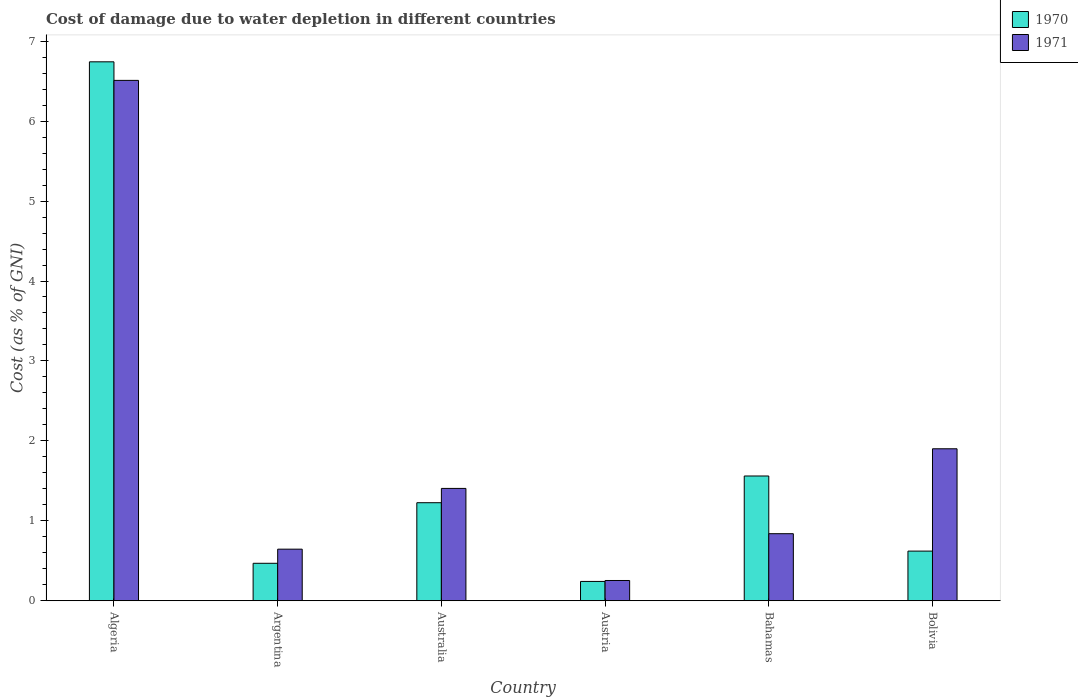How many different coloured bars are there?
Your answer should be compact. 2. How many groups of bars are there?
Make the answer very short. 6. Are the number of bars on each tick of the X-axis equal?
Offer a very short reply. Yes. How many bars are there on the 1st tick from the left?
Provide a short and direct response. 2. What is the label of the 3rd group of bars from the left?
Provide a short and direct response. Australia. In how many cases, is the number of bars for a given country not equal to the number of legend labels?
Your answer should be very brief. 0. What is the cost of damage caused due to water depletion in 1971 in Australia?
Provide a succinct answer. 1.41. Across all countries, what is the maximum cost of damage caused due to water depletion in 1970?
Offer a very short reply. 6.74. Across all countries, what is the minimum cost of damage caused due to water depletion in 1970?
Provide a succinct answer. 0.24. In which country was the cost of damage caused due to water depletion in 1971 maximum?
Offer a terse response. Algeria. In which country was the cost of damage caused due to water depletion in 1971 minimum?
Give a very brief answer. Austria. What is the total cost of damage caused due to water depletion in 1970 in the graph?
Keep it short and to the point. 10.86. What is the difference between the cost of damage caused due to water depletion in 1970 in Argentina and that in Bahamas?
Provide a succinct answer. -1.09. What is the difference between the cost of damage caused due to water depletion in 1971 in Australia and the cost of damage caused due to water depletion in 1970 in Algeria?
Your answer should be very brief. -5.34. What is the average cost of damage caused due to water depletion in 1971 per country?
Your answer should be compact. 1.93. What is the difference between the cost of damage caused due to water depletion of/in 1971 and cost of damage caused due to water depletion of/in 1970 in Australia?
Provide a succinct answer. 0.18. In how many countries, is the cost of damage caused due to water depletion in 1971 greater than 4.6 %?
Your answer should be very brief. 1. What is the ratio of the cost of damage caused due to water depletion in 1971 in Algeria to that in Australia?
Ensure brevity in your answer.  4.63. Is the difference between the cost of damage caused due to water depletion in 1971 in Algeria and Argentina greater than the difference between the cost of damage caused due to water depletion in 1970 in Algeria and Argentina?
Provide a short and direct response. No. What is the difference between the highest and the second highest cost of damage caused due to water depletion in 1971?
Your response must be concise. -4.61. What is the difference between the highest and the lowest cost of damage caused due to water depletion in 1970?
Make the answer very short. 6.5. What does the 2nd bar from the left in Argentina represents?
Provide a short and direct response. 1971. What does the 2nd bar from the right in Bolivia represents?
Your answer should be compact. 1970. Are all the bars in the graph horizontal?
Ensure brevity in your answer.  No. What is the difference between two consecutive major ticks on the Y-axis?
Provide a succinct answer. 1. Does the graph contain any zero values?
Your response must be concise. No. Does the graph contain grids?
Make the answer very short. No. How are the legend labels stacked?
Your answer should be compact. Vertical. What is the title of the graph?
Give a very brief answer. Cost of damage due to water depletion in different countries. What is the label or title of the Y-axis?
Provide a short and direct response. Cost (as % of GNI). What is the Cost (as % of GNI) of 1970 in Algeria?
Offer a very short reply. 6.74. What is the Cost (as % of GNI) of 1971 in Algeria?
Offer a terse response. 6.51. What is the Cost (as % of GNI) in 1970 in Argentina?
Your answer should be compact. 0.47. What is the Cost (as % of GNI) of 1971 in Argentina?
Offer a very short reply. 0.65. What is the Cost (as % of GNI) of 1970 in Australia?
Your answer should be very brief. 1.23. What is the Cost (as % of GNI) of 1971 in Australia?
Keep it short and to the point. 1.41. What is the Cost (as % of GNI) in 1970 in Austria?
Provide a succinct answer. 0.24. What is the Cost (as % of GNI) of 1971 in Austria?
Keep it short and to the point. 0.25. What is the Cost (as % of GNI) in 1970 in Bahamas?
Provide a succinct answer. 1.56. What is the Cost (as % of GNI) of 1971 in Bahamas?
Provide a succinct answer. 0.84. What is the Cost (as % of GNI) of 1970 in Bolivia?
Provide a short and direct response. 0.62. What is the Cost (as % of GNI) in 1971 in Bolivia?
Make the answer very short. 1.9. Across all countries, what is the maximum Cost (as % of GNI) in 1970?
Give a very brief answer. 6.74. Across all countries, what is the maximum Cost (as % of GNI) of 1971?
Provide a succinct answer. 6.51. Across all countries, what is the minimum Cost (as % of GNI) in 1970?
Make the answer very short. 0.24. Across all countries, what is the minimum Cost (as % of GNI) in 1971?
Your response must be concise. 0.25. What is the total Cost (as % of GNI) of 1970 in the graph?
Give a very brief answer. 10.86. What is the total Cost (as % of GNI) in 1971 in the graph?
Offer a terse response. 11.55. What is the difference between the Cost (as % of GNI) of 1970 in Algeria and that in Argentina?
Provide a succinct answer. 6.27. What is the difference between the Cost (as % of GNI) of 1971 in Algeria and that in Argentina?
Provide a short and direct response. 5.86. What is the difference between the Cost (as % of GNI) in 1970 in Algeria and that in Australia?
Provide a succinct answer. 5.52. What is the difference between the Cost (as % of GNI) of 1971 in Algeria and that in Australia?
Make the answer very short. 5.1. What is the difference between the Cost (as % of GNI) in 1970 in Algeria and that in Austria?
Make the answer very short. 6.5. What is the difference between the Cost (as % of GNI) in 1971 in Algeria and that in Austria?
Offer a terse response. 6.26. What is the difference between the Cost (as % of GNI) in 1970 in Algeria and that in Bahamas?
Offer a very short reply. 5.18. What is the difference between the Cost (as % of GNI) in 1971 in Algeria and that in Bahamas?
Ensure brevity in your answer.  5.67. What is the difference between the Cost (as % of GNI) in 1970 in Algeria and that in Bolivia?
Provide a short and direct response. 6.12. What is the difference between the Cost (as % of GNI) of 1971 in Algeria and that in Bolivia?
Provide a succinct answer. 4.61. What is the difference between the Cost (as % of GNI) of 1970 in Argentina and that in Australia?
Offer a terse response. -0.76. What is the difference between the Cost (as % of GNI) of 1971 in Argentina and that in Australia?
Provide a short and direct response. -0.76. What is the difference between the Cost (as % of GNI) in 1970 in Argentina and that in Austria?
Your answer should be very brief. 0.23. What is the difference between the Cost (as % of GNI) in 1971 in Argentina and that in Austria?
Your answer should be compact. 0.39. What is the difference between the Cost (as % of GNI) in 1970 in Argentina and that in Bahamas?
Keep it short and to the point. -1.09. What is the difference between the Cost (as % of GNI) of 1971 in Argentina and that in Bahamas?
Your response must be concise. -0.19. What is the difference between the Cost (as % of GNI) in 1970 in Argentina and that in Bolivia?
Give a very brief answer. -0.15. What is the difference between the Cost (as % of GNI) in 1971 in Argentina and that in Bolivia?
Keep it short and to the point. -1.26. What is the difference between the Cost (as % of GNI) in 1970 in Australia and that in Austria?
Offer a very short reply. 0.98. What is the difference between the Cost (as % of GNI) of 1971 in Australia and that in Austria?
Make the answer very short. 1.15. What is the difference between the Cost (as % of GNI) in 1970 in Australia and that in Bahamas?
Make the answer very short. -0.33. What is the difference between the Cost (as % of GNI) of 1971 in Australia and that in Bahamas?
Keep it short and to the point. 0.57. What is the difference between the Cost (as % of GNI) of 1970 in Australia and that in Bolivia?
Your answer should be very brief. 0.61. What is the difference between the Cost (as % of GNI) of 1971 in Australia and that in Bolivia?
Offer a very short reply. -0.5. What is the difference between the Cost (as % of GNI) in 1970 in Austria and that in Bahamas?
Offer a very short reply. -1.32. What is the difference between the Cost (as % of GNI) in 1971 in Austria and that in Bahamas?
Provide a short and direct response. -0.59. What is the difference between the Cost (as % of GNI) in 1970 in Austria and that in Bolivia?
Keep it short and to the point. -0.38. What is the difference between the Cost (as % of GNI) of 1971 in Austria and that in Bolivia?
Ensure brevity in your answer.  -1.65. What is the difference between the Cost (as % of GNI) in 1970 in Bahamas and that in Bolivia?
Ensure brevity in your answer.  0.94. What is the difference between the Cost (as % of GNI) in 1971 in Bahamas and that in Bolivia?
Give a very brief answer. -1.06. What is the difference between the Cost (as % of GNI) of 1970 in Algeria and the Cost (as % of GNI) of 1971 in Argentina?
Keep it short and to the point. 6.1. What is the difference between the Cost (as % of GNI) of 1970 in Algeria and the Cost (as % of GNI) of 1971 in Australia?
Provide a short and direct response. 5.34. What is the difference between the Cost (as % of GNI) in 1970 in Algeria and the Cost (as % of GNI) in 1971 in Austria?
Keep it short and to the point. 6.49. What is the difference between the Cost (as % of GNI) of 1970 in Algeria and the Cost (as % of GNI) of 1971 in Bahamas?
Offer a very short reply. 5.9. What is the difference between the Cost (as % of GNI) of 1970 in Algeria and the Cost (as % of GNI) of 1971 in Bolivia?
Ensure brevity in your answer.  4.84. What is the difference between the Cost (as % of GNI) in 1970 in Argentina and the Cost (as % of GNI) in 1971 in Australia?
Your response must be concise. -0.94. What is the difference between the Cost (as % of GNI) in 1970 in Argentina and the Cost (as % of GNI) in 1971 in Austria?
Your answer should be very brief. 0.22. What is the difference between the Cost (as % of GNI) of 1970 in Argentina and the Cost (as % of GNI) of 1971 in Bahamas?
Your answer should be compact. -0.37. What is the difference between the Cost (as % of GNI) of 1970 in Argentina and the Cost (as % of GNI) of 1971 in Bolivia?
Your answer should be compact. -1.43. What is the difference between the Cost (as % of GNI) in 1970 in Australia and the Cost (as % of GNI) in 1971 in Austria?
Ensure brevity in your answer.  0.97. What is the difference between the Cost (as % of GNI) in 1970 in Australia and the Cost (as % of GNI) in 1971 in Bahamas?
Provide a short and direct response. 0.39. What is the difference between the Cost (as % of GNI) in 1970 in Australia and the Cost (as % of GNI) in 1971 in Bolivia?
Ensure brevity in your answer.  -0.67. What is the difference between the Cost (as % of GNI) of 1970 in Austria and the Cost (as % of GNI) of 1971 in Bahamas?
Provide a succinct answer. -0.6. What is the difference between the Cost (as % of GNI) in 1970 in Austria and the Cost (as % of GNI) in 1971 in Bolivia?
Your response must be concise. -1.66. What is the difference between the Cost (as % of GNI) of 1970 in Bahamas and the Cost (as % of GNI) of 1971 in Bolivia?
Your answer should be compact. -0.34. What is the average Cost (as % of GNI) of 1970 per country?
Offer a terse response. 1.81. What is the average Cost (as % of GNI) in 1971 per country?
Offer a terse response. 1.93. What is the difference between the Cost (as % of GNI) in 1970 and Cost (as % of GNI) in 1971 in Algeria?
Your response must be concise. 0.23. What is the difference between the Cost (as % of GNI) in 1970 and Cost (as % of GNI) in 1971 in Argentina?
Provide a short and direct response. -0.18. What is the difference between the Cost (as % of GNI) of 1970 and Cost (as % of GNI) of 1971 in Australia?
Your answer should be compact. -0.18. What is the difference between the Cost (as % of GNI) of 1970 and Cost (as % of GNI) of 1971 in Austria?
Make the answer very short. -0.01. What is the difference between the Cost (as % of GNI) of 1970 and Cost (as % of GNI) of 1971 in Bahamas?
Keep it short and to the point. 0.72. What is the difference between the Cost (as % of GNI) in 1970 and Cost (as % of GNI) in 1971 in Bolivia?
Make the answer very short. -1.28. What is the ratio of the Cost (as % of GNI) in 1970 in Algeria to that in Argentina?
Offer a terse response. 14.38. What is the ratio of the Cost (as % of GNI) in 1971 in Algeria to that in Argentina?
Ensure brevity in your answer.  10.08. What is the ratio of the Cost (as % of GNI) in 1970 in Algeria to that in Australia?
Provide a succinct answer. 5.5. What is the ratio of the Cost (as % of GNI) of 1971 in Algeria to that in Australia?
Your answer should be very brief. 4.63. What is the ratio of the Cost (as % of GNI) in 1970 in Algeria to that in Austria?
Keep it short and to the point. 27.86. What is the ratio of the Cost (as % of GNI) of 1971 in Algeria to that in Austria?
Offer a very short reply. 25.65. What is the ratio of the Cost (as % of GNI) in 1970 in Algeria to that in Bahamas?
Keep it short and to the point. 4.32. What is the ratio of the Cost (as % of GNI) in 1971 in Algeria to that in Bahamas?
Offer a very short reply. 7.76. What is the ratio of the Cost (as % of GNI) of 1970 in Algeria to that in Bolivia?
Your answer should be very brief. 10.85. What is the ratio of the Cost (as % of GNI) of 1971 in Algeria to that in Bolivia?
Provide a succinct answer. 3.42. What is the ratio of the Cost (as % of GNI) of 1970 in Argentina to that in Australia?
Make the answer very short. 0.38. What is the ratio of the Cost (as % of GNI) in 1971 in Argentina to that in Australia?
Offer a very short reply. 0.46. What is the ratio of the Cost (as % of GNI) in 1970 in Argentina to that in Austria?
Ensure brevity in your answer.  1.94. What is the ratio of the Cost (as % of GNI) in 1971 in Argentina to that in Austria?
Make the answer very short. 2.54. What is the ratio of the Cost (as % of GNI) of 1970 in Argentina to that in Bahamas?
Give a very brief answer. 0.3. What is the ratio of the Cost (as % of GNI) in 1971 in Argentina to that in Bahamas?
Offer a terse response. 0.77. What is the ratio of the Cost (as % of GNI) of 1970 in Argentina to that in Bolivia?
Give a very brief answer. 0.75. What is the ratio of the Cost (as % of GNI) in 1971 in Argentina to that in Bolivia?
Your answer should be compact. 0.34. What is the ratio of the Cost (as % of GNI) in 1970 in Australia to that in Austria?
Give a very brief answer. 5.07. What is the ratio of the Cost (as % of GNI) in 1971 in Australia to that in Austria?
Your answer should be very brief. 5.54. What is the ratio of the Cost (as % of GNI) of 1970 in Australia to that in Bahamas?
Keep it short and to the point. 0.79. What is the ratio of the Cost (as % of GNI) in 1971 in Australia to that in Bahamas?
Your answer should be compact. 1.67. What is the ratio of the Cost (as % of GNI) in 1970 in Australia to that in Bolivia?
Your response must be concise. 1.97. What is the ratio of the Cost (as % of GNI) of 1971 in Australia to that in Bolivia?
Make the answer very short. 0.74. What is the ratio of the Cost (as % of GNI) of 1970 in Austria to that in Bahamas?
Give a very brief answer. 0.15. What is the ratio of the Cost (as % of GNI) of 1971 in Austria to that in Bahamas?
Your answer should be very brief. 0.3. What is the ratio of the Cost (as % of GNI) in 1970 in Austria to that in Bolivia?
Offer a terse response. 0.39. What is the ratio of the Cost (as % of GNI) of 1971 in Austria to that in Bolivia?
Offer a very short reply. 0.13. What is the ratio of the Cost (as % of GNI) of 1970 in Bahamas to that in Bolivia?
Your response must be concise. 2.51. What is the ratio of the Cost (as % of GNI) in 1971 in Bahamas to that in Bolivia?
Ensure brevity in your answer.  0.44. What is the difference between the highest and the second highest Cost (as % of GNI) in 1970?
Keep it short and to the point. 5.18. What is the difference between the highest and the second highest Cost (as % of GNI) of 1971?
Give a very brief answer. 4.61. What is the difference between the highest and the lowest Cost (as % of GNI) in 1970?
Offer a terse response. 6.5. What is the difference between the highest and the lowest Cost (as % of GNI) in 1971?
Your answer should be compact. 6.26. 